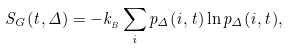<formula> <loc_0><loc_0><loc_500><loc_500>S _ { G } ( t , \Delta ) = - k _ { _ { B } } \sum _ { i } p _ { \Delta } ( i , t ) \ln p _ { \Delta } ( i , t ) ,</formula> 